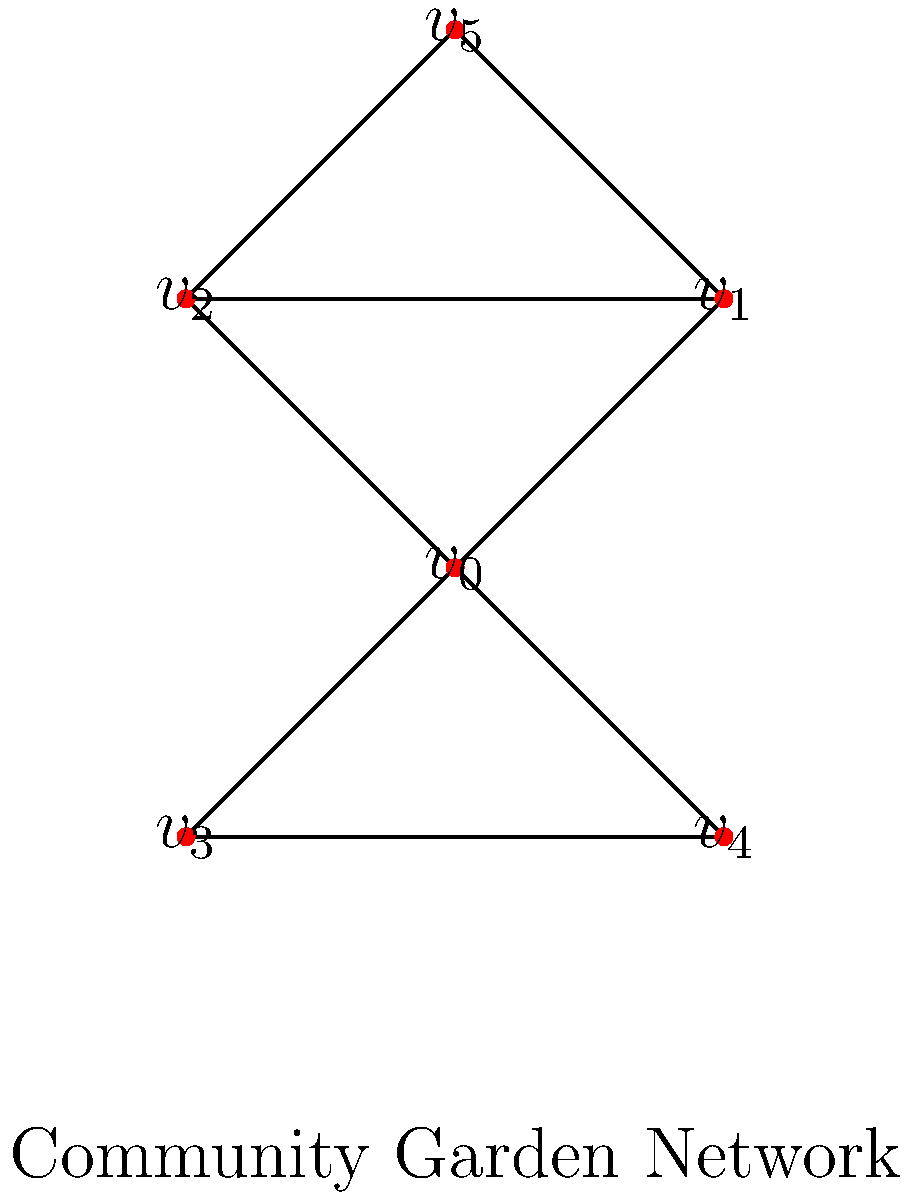In the community garden network graph shown above, which vertex has the highest degree centrality, and what does this imply about its role in the garden community? To answer this question, we need to follow these steps:

1. Understand degree centrality:
   Degree centrality is the number of direct connections a vertex has to other vertices in the graph.

2. Count the connections for each vertex:
   $v_0$: 4 connections
   $v_1$: 3 connections
   $v_2$: 3 connections
   $v_3$: 2 connections
   $v_4$: 2 connections
   $v_5$: 2 connections

3. Identify the vertex with the highest degree centrality:
   $v_0$ has the highest degree centrality with 4 connections.

4. Interpret the meaning in the context of the community garden:
   The vertex with the highest degree centrality ($v_0$) represents the most connected member in the community garden network. This person likely plays a central role in communication, coordination, and information sharing within the garden community.

5. Consider the implications:
   This individual might be responsible for organizing events, distributing resources, or mediating between different groups within the community garden. Their position suggests they are a key figure in maintaining the cohesion and functionality of the garden network.
Answer: $v_0$; central coordinator and communicator in the garden community 